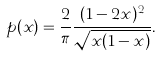<formula> <loc_0><loc_0><loc_500><loc_500>p ( x ) = \frac { 2 } { \pi } \frac { ( 1 - 2 x ) ^ { 2 } } { \sqrt { x ( 1 - x ) } } .</formula> 